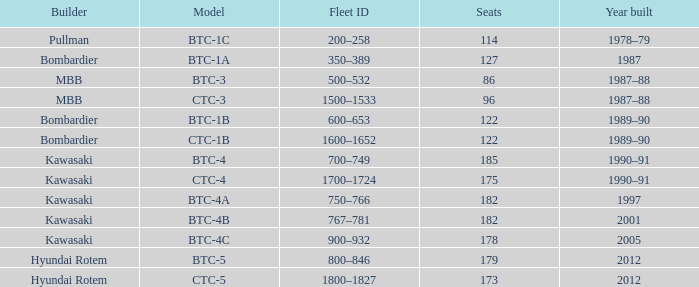How many seats does the BTC-5 model have? 179.0. Help me parse the entirety of this table. {'header': ['Builder', 'Model', 'Fleet ID', 'Seats', 'Year built'], 'rows': [['Pullman', 'BTC-1C', '200–258', '114', '1978–79'], ['Bombardier', 'BTC-1A', '350–389', '127', '1987'], ['MBB', 'BTC-3', '500–532', '86', '1987–88'], ['MBB', 'CTC-3', '1500–1533', '96', '1987–88'], ['Bombardier', 'BTC-1B', '600–653', '122', '1989–90'], ['Bombardier', 'CTC-1B', '1600–1652', '122', '1989–90'], ['Kawasaki', 'BTC-4', '700–749', '185', '1990–91'], ['Kawasaki', 'CTC-4', '1700–1724', '175', '1990–91'], ['Kawasaki', 'BTC-4A', '750–766', '182', '1997'], ['Kawasaki', 'BTC-4B', '767–781', '182', '2001'], ['Kawasaki', 'BTC-4C', '900–932', '178', '2005'], ['Hyundai Rotem', 'BTC-5', '800–846', '179', '2012'], ['Hyundai Rotem', 'CTC-5', '1800–1827', '173', '2012']]} 